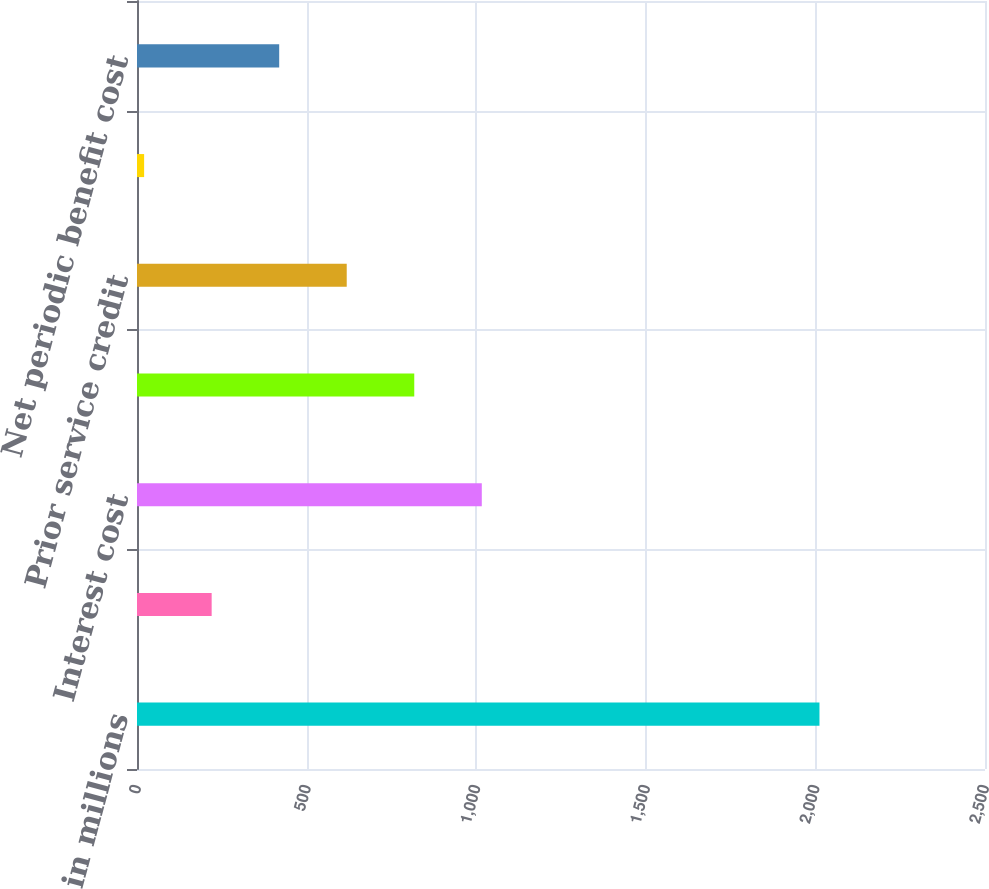Convert chart to OTSL. <chart><loc_0><loc_0><loc_500><loc_500><bar_chart><fcel>in millions<fcel>Service cost<fcel>Interest cost<fcel>Expected return on plan assets<fcel>Prior service credit<fcel>Net loss from previous years<fcel>Net periodic benefit cost<nl><fcel>2012<fcel>220.1<fcel>1016.5<fcel>817.4<fcel>618.3<fcel>21<fcel>419.2<nl></chart> 